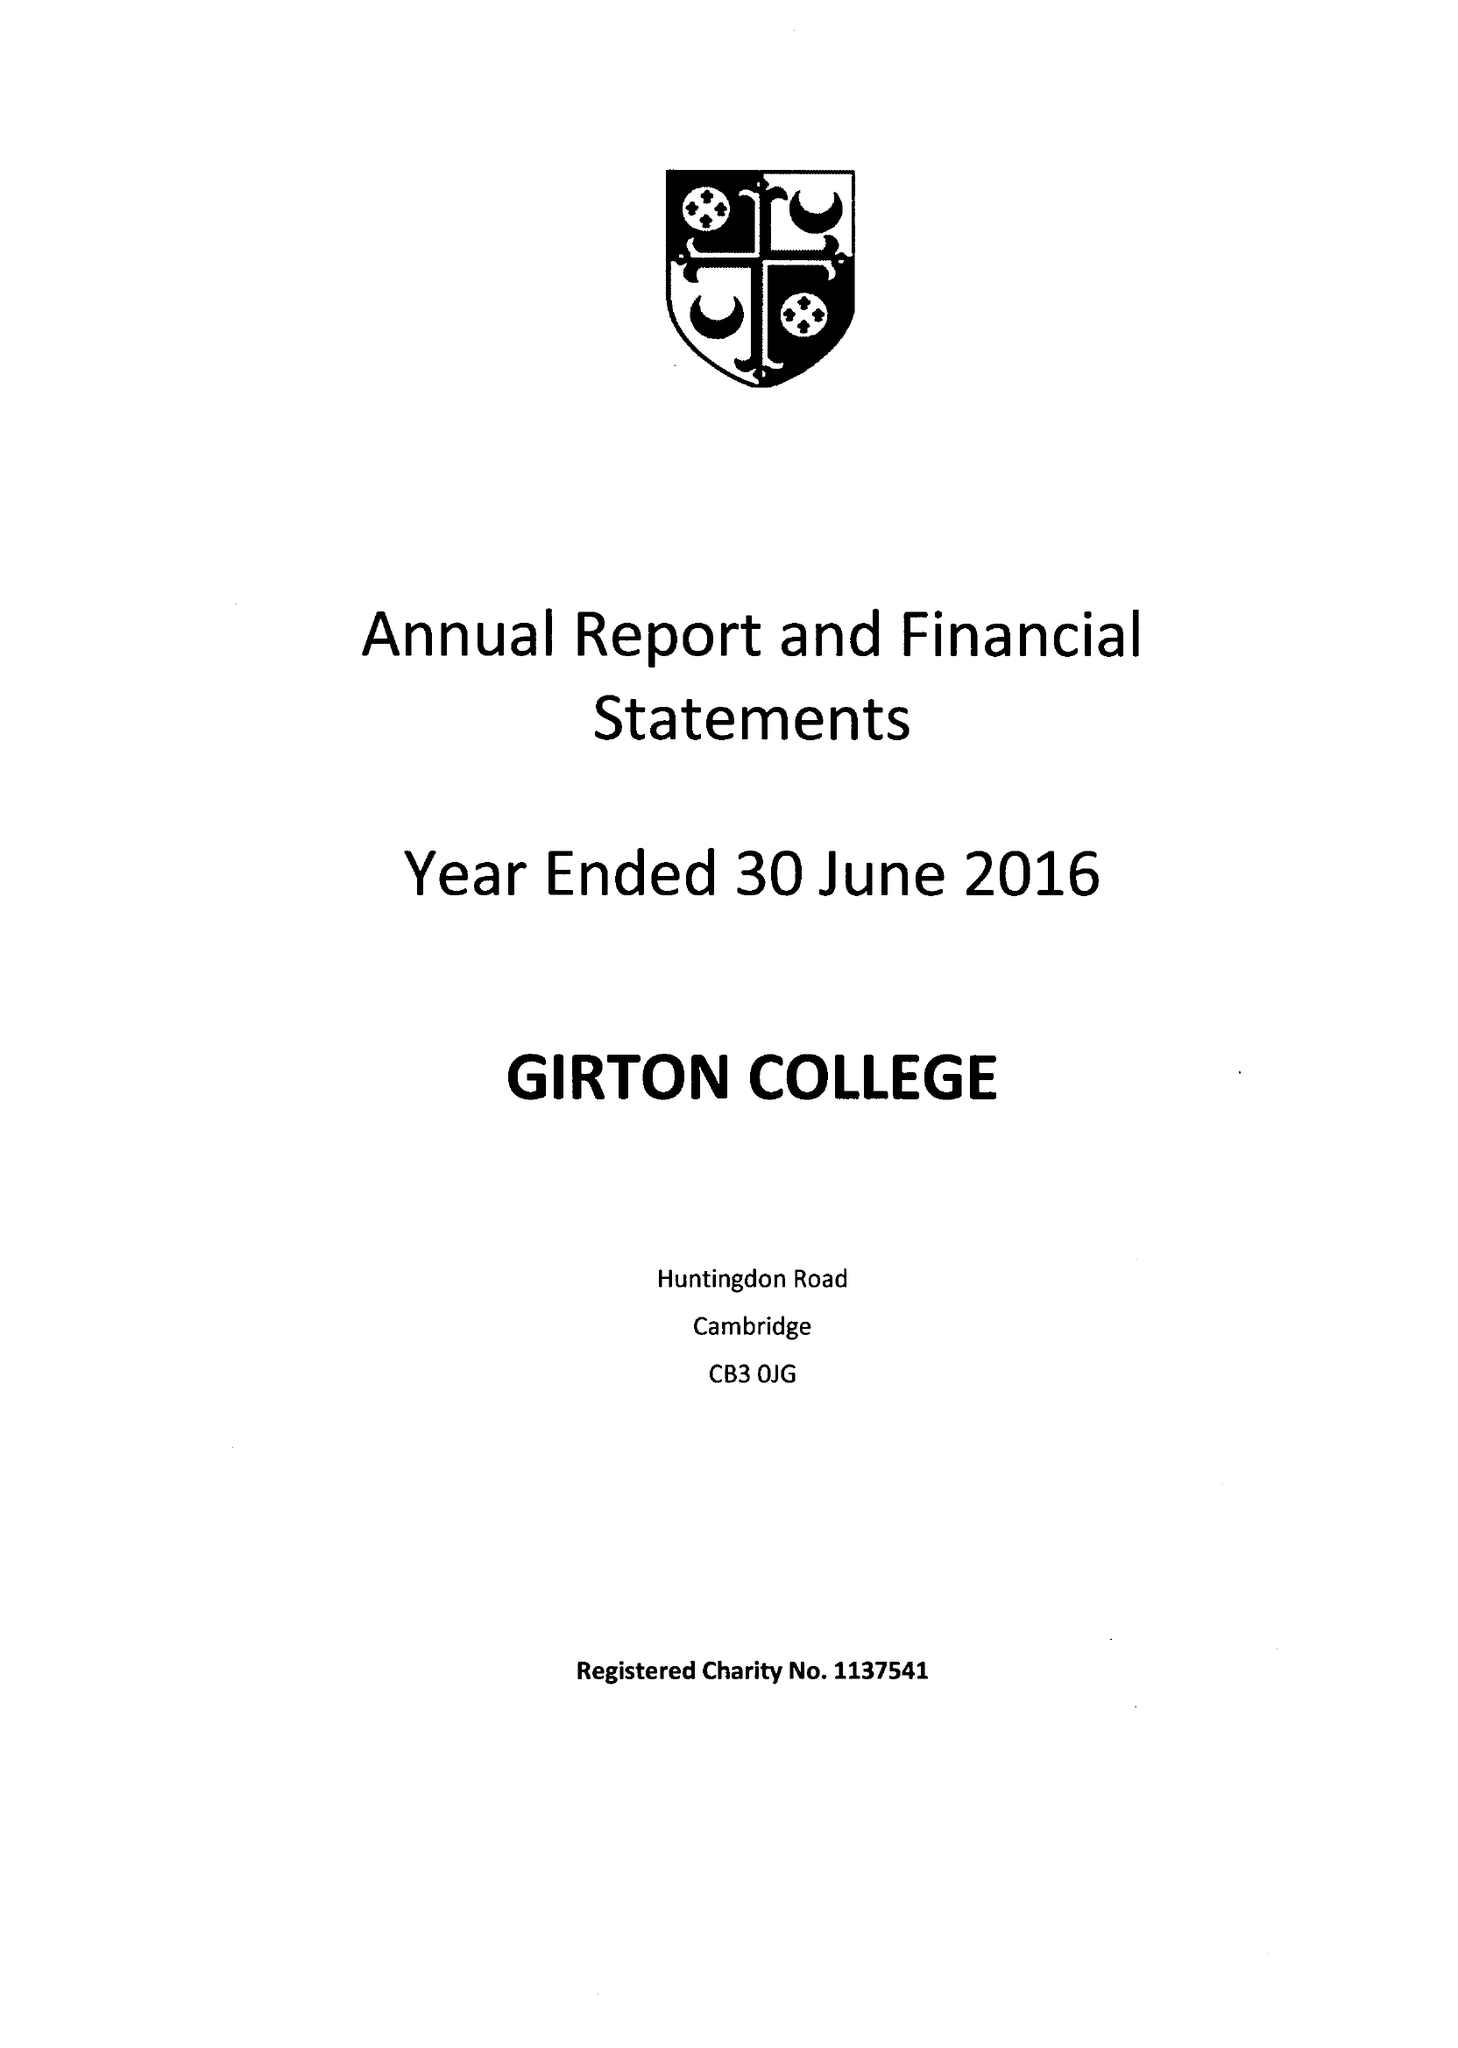What is the value for the charity_name?
Answer the question using a single word or phrase. Girton College 